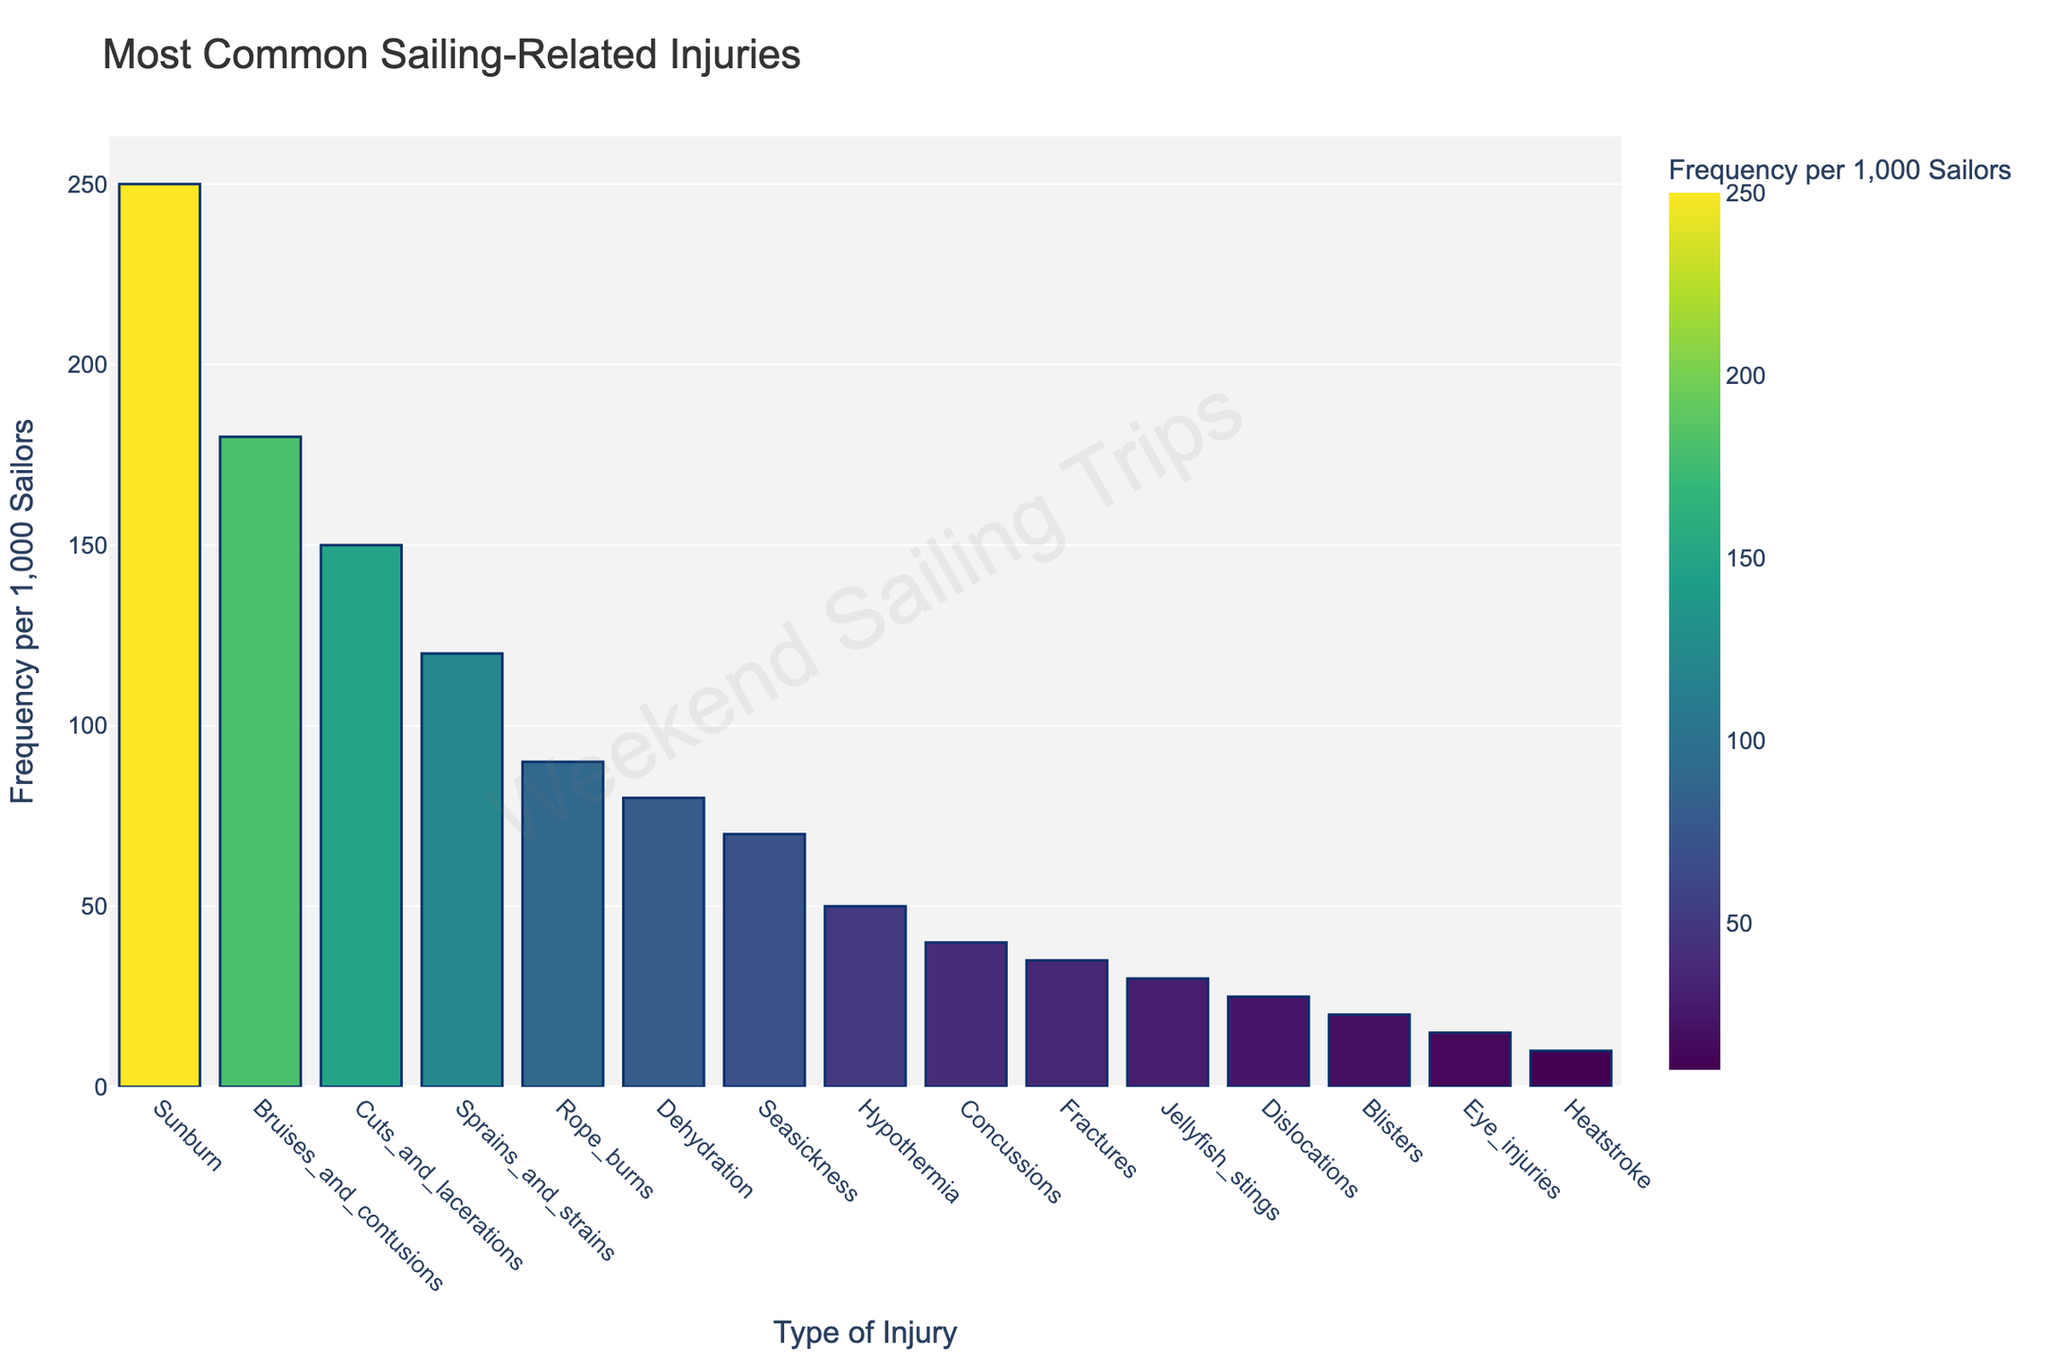What is the most common sailing-related injury? The tallest bar in the figure represents the most frequent injury. In this case, "Sunburn" has the highest frequency bar.
Answer: Sunburn Which injury has a frequency closest to 100 per 1,000 sailors? By inspecting the heights of the bars, "Rope burns" has a frequency of 90 per 1,000 sailors, which is closest to 100.
Answer: Rope burns How many injuries have a frequency of 50 per 1,000 sailors or less? By counting the bars that are at 50 or below, we find that Hypothermia, Concussions, Fractures, Jellyfish stings, Dislocations, Blisters, Eye injuries, and Heatstroke all fit this criterion. There are 8 such injuries in total.
Answer: 8 Are there more injuries with a frequency greater than 100 per 1,000 sailors or less than 100 per 1,000 sailors? Count the number of bars above 100 and below 100. There are 5 bars above 100 and 10 bars below 100. Therefore, there are more injuries with a frequency less than 100 per 1,000 sailors.
Answer: More injuries with less than 100 per 1,000 sailors What is the combined frequency of the top three most common injuries? Sum the frequencies of the top three bars, which correspond to Sunburn (250), Bruises and contusions (180), and Cuts and lacerations (150). So, 250 + 180 + 150 = 580.
Answer: 580 Which has a higher frequency, Seasickness or Dehydration? Compare the heights of the bars and their respective values. Dehydration is 80 and Seasickness is 70, so Dehydration has a higher frequency.
Answer: Dehydration What is the difference in frequency between Blisters and Eye injuries? Subtract the frequency of Eye injuries from Blisters: 20 - 15 = 5.
Answer: 5 Which injury is represented by the color with the highest value on the color scale? The color scale is based on frequency, with the highest frequency represented by the color at the highest value. The highest frequency is 250, which corresponds to Sunburn.
Answer: Sunburn How much more common is Sunburn compared to Fractures? Subtract the frequency of Fractures from Sunburn: 250 - 35 = 215.
Answer: 215 What is the average frequency of the injuries listed in the figure? Sum the frequencies of all injuries and divide by the number of injuries. The total sum is 250 + 180 + 150 + 120 + 90 + 80 + 70 + 50 + 40 + 35 + 30 + 25 + 20 + 15 + 10 = 1165. There are 15 injuries, so the average frequency is 1165 / 15 ≈ 77.67.
Answer: 77.67 